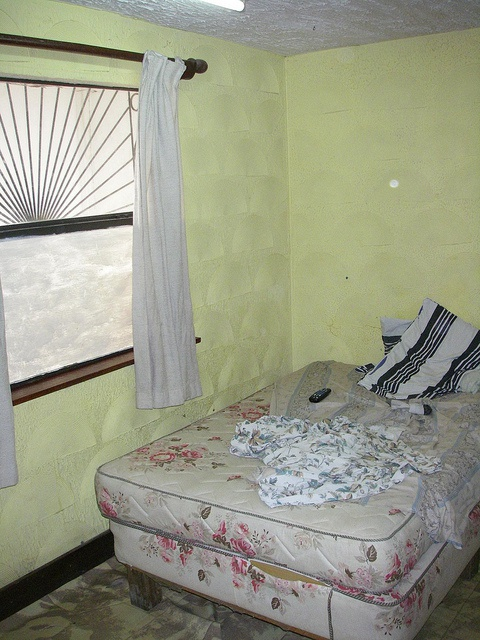Describe the objects in this image and their specific colors. I can see a bed in darkgray, gray, and black tones in this image. 